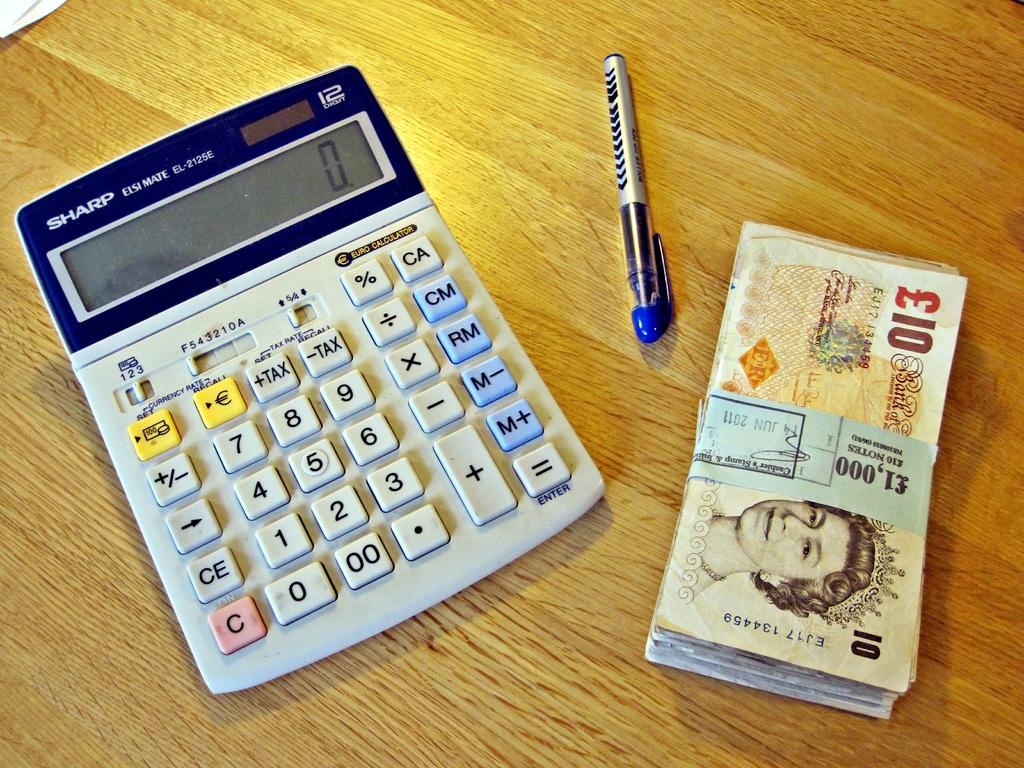What brand of calculator is this?
Give a very brief answer. Sharp. What is this calculators model name?
Give a very brief answer. Sharp. 